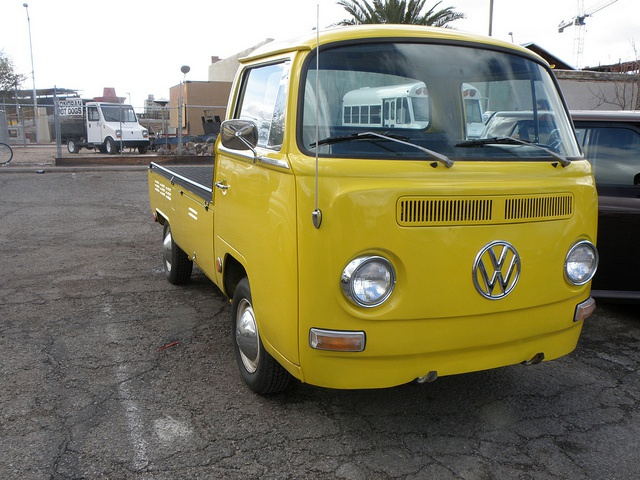Describe the objects in this image and their specific colors. I can see truck in white, olive, gray, and black tones, car in white, black, gray, navy, and blue tones, bus in white, lightblue, darkgray, and gray tones, truck in white, gray, lightgray, darkgray, and black tones, and bicycle in white, gray, and black tones in this image. 